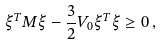<formula> <loc_0><loc_0><loc_500><loc_500>\xi ^ { T } M \xi - \frac { 3 } { 2 } V _ { 0 } \xi ^ { T } \xi \geq 0 \, ,</formula> 